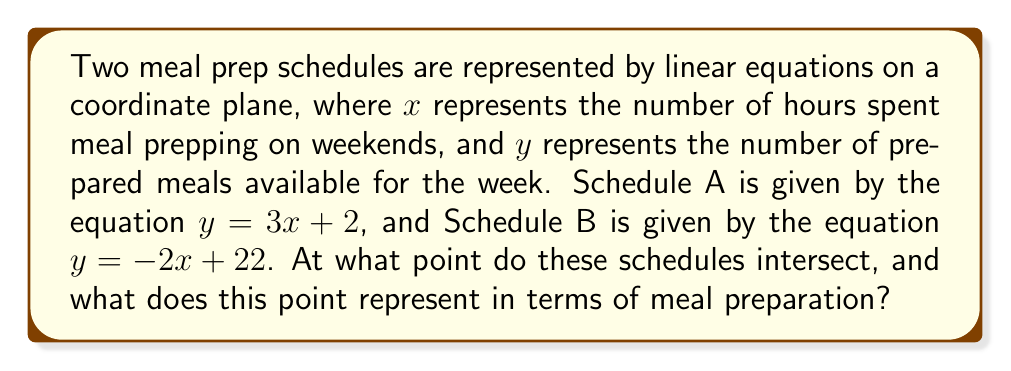Provide a solution to this math problem. To find the intersection point of the two meal prep schedules, we need to solve the system of equations:

$$\begin{cases}
y = 3x + 2 \\
y = -2x + 22
\end{cases}$$

1. Set the equations equal to each other:
   $3x + 2 = -2x + 22$

2. Solve for $x$:
   $3x + 2x = 22 - 2$
   $5x = 20$
   $x = 4$

3. Substitute $x = 4$ into either equation to find $y$:
   $y = 3(4) + 2 = 14$

4. The intersection point is $(4, 14)$

Interpretation:
The point $(4, 14)$ represents the schedule where both meal prep plans produce the same number of meals. This means that spending 4 hours meal prepping on the weekend will result in 14 prepared meals for the week, regardless of which schedule is followed.

[asy]
size(200);
import graph;

xaxis("Hours spent meal prepping", arrow=Arrow);
yaxis("Number of prepared meals", arrow=Arrow);

real f(real x) {return 3x + 2;}
real g(real x) {return -2x + 22;}

draw(graph(f, 0, 7), blue, "Schedule A");
draw(graph(g, 0, 11), red, "Schedule B");

dot((4,14), brown);
label("(4, 14)", (4,14), NE);

[/asy]
Answer: The schedules intersect at the point $(4, 14)$, which represents 4 hours of meal prep time resulting in 14 prepared meals for the week. 